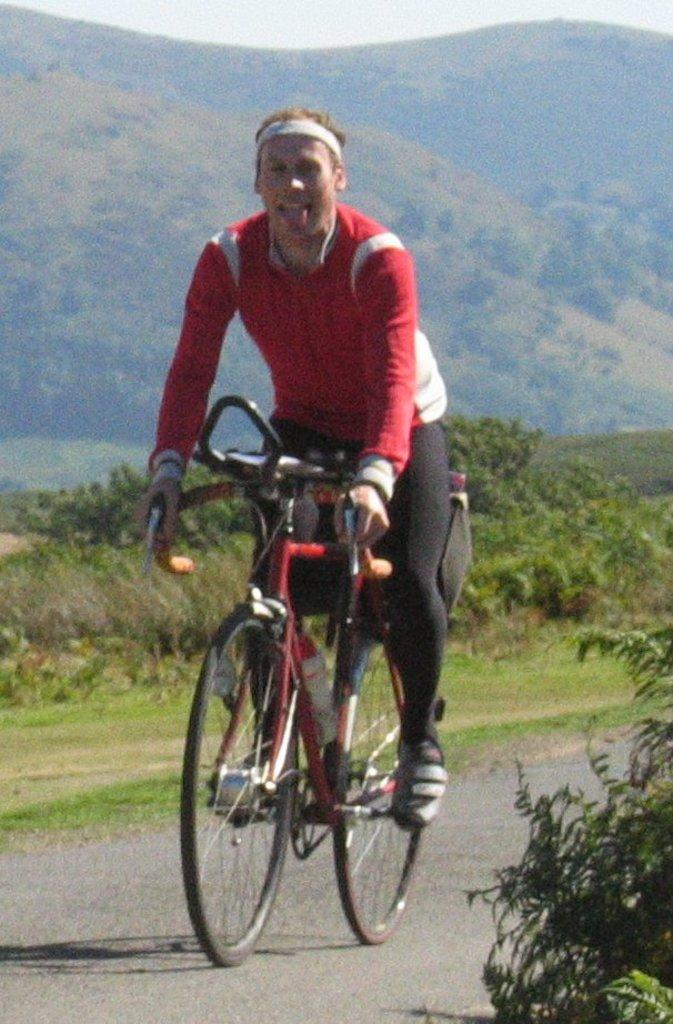What is the man in the image doing? The man is riding a bicycle in the image. What color is the t-shirt the man is wearing? The man is wearing a red t-shirt. What can be seen in the background of the image? There are mountains and plants in the background of the image. What type of beef can be seen hanging from the bicycle in the image? There is no beef present in the image, and the man is not carrying any beef while riding the bicycle. Can you tell me how many scales are visible on the man's t-shirt? The man's t-shirt is red and does not have any scales on it. What is the man using to ride the bicycle in the image? The man is using the bicycle itself to ride, not a tin or any other material. 